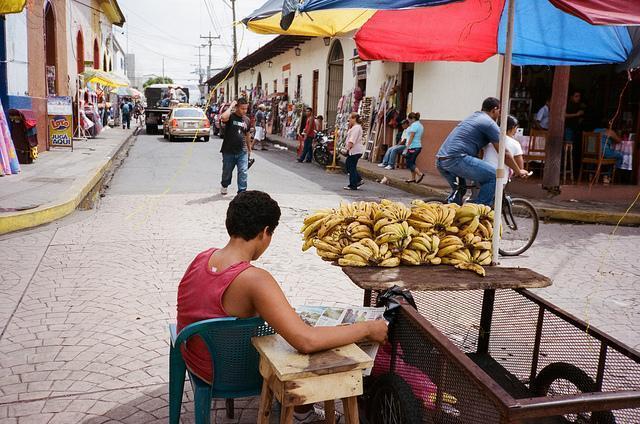How many men are wearing red tanks?
Give a very brief answer. 1. How many people are there?
Give a very brief answer. 3. 